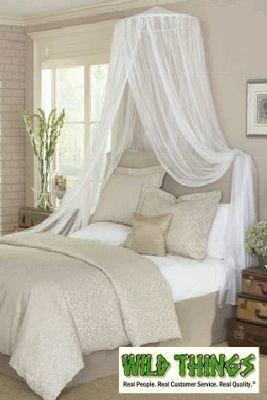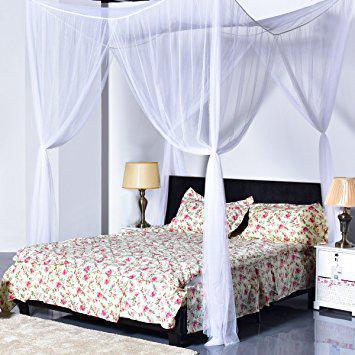The first image is the image on the left, the second image is the image on the right. For the images displayed, is the sentence "In at least one image there is a squared canopy with two of the lace curtains tied to the end of the bed poles." factually correct? Answer yes or no. Yes. The first image is the image on the left, the second image is the image on the right. For the images shown, is this caption "One image shows a ceiling-suspended gauzy white canopy that hangs over the middle of a bed in a cone shape that extends around most of the bed." true? Answer yes or no. No. 